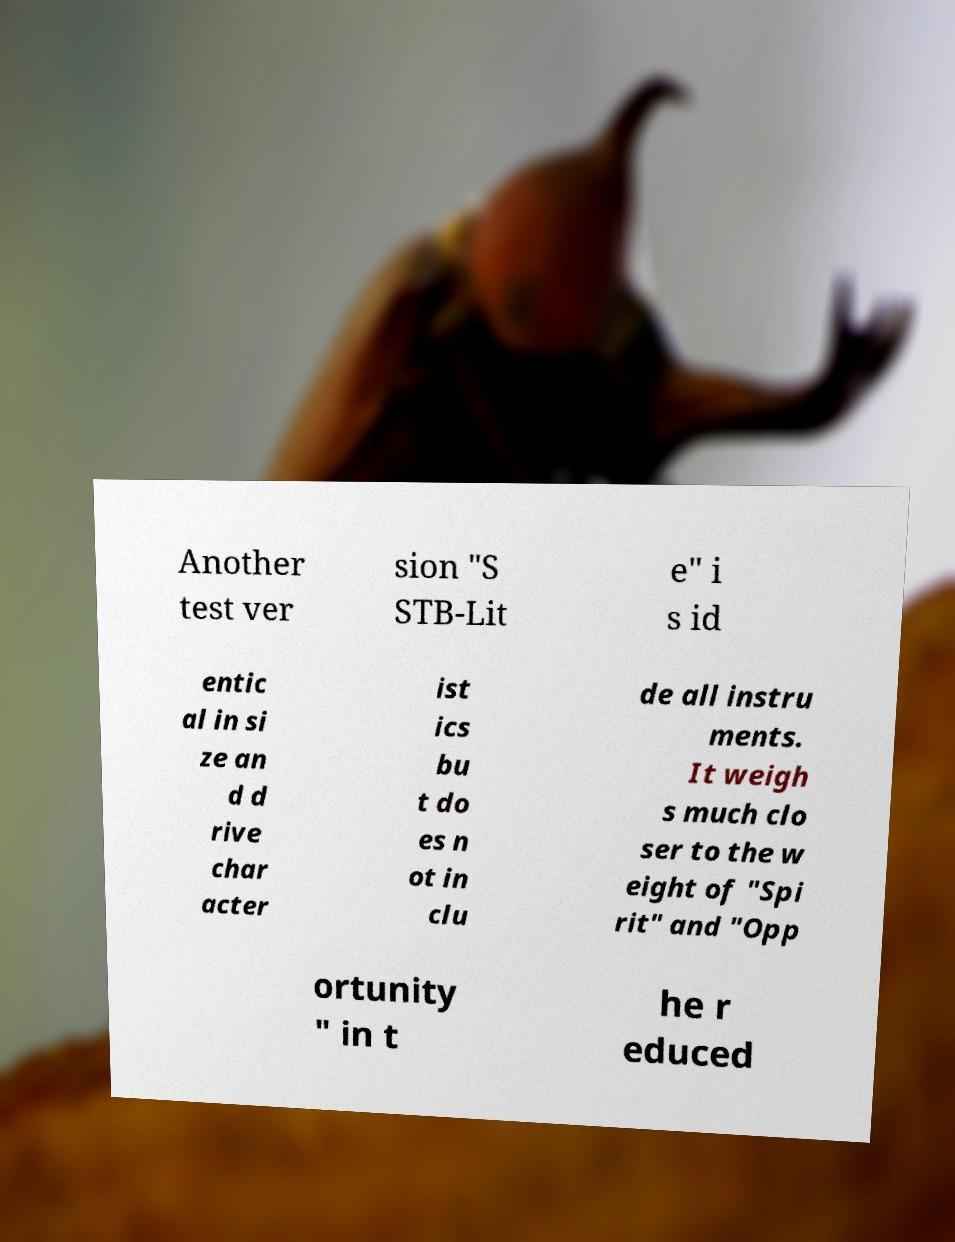Could you assist in decoding the text presented in this image and type it out clearly? Another test ver sion "S STB-Lit e" i s id entic al in si ze an d d rive char acter ist ics bu t do es n ot in clu de all instru ments. It weigh s much clo ser to the w eight of "Spi rit" and "Opp ortunity " in t he r educed 